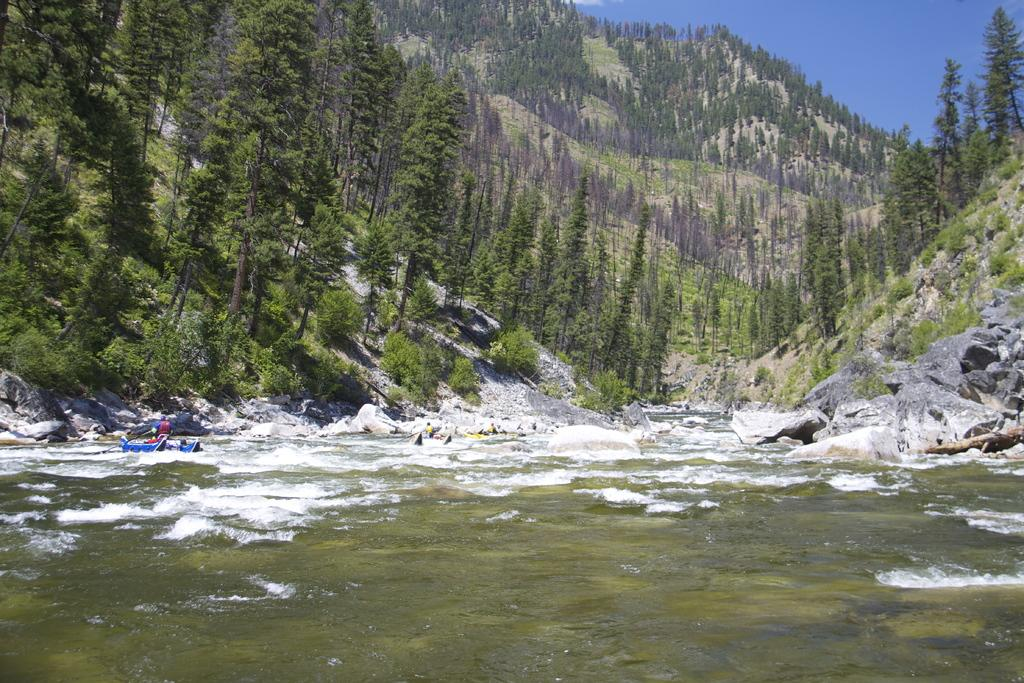What is the primary element in the image? There is water in the image. What is on the water? There are boats on the water. What else can be seen in the image besides the water and boats? There are rocks, people in the boats, trees, hills, and the sky visible in the background of the image. What type of wood is used to build the boats in the image? There is no information about the type of wood used to build the boats in the image. Additionally, the image does not show the boats being built, only their final form. 